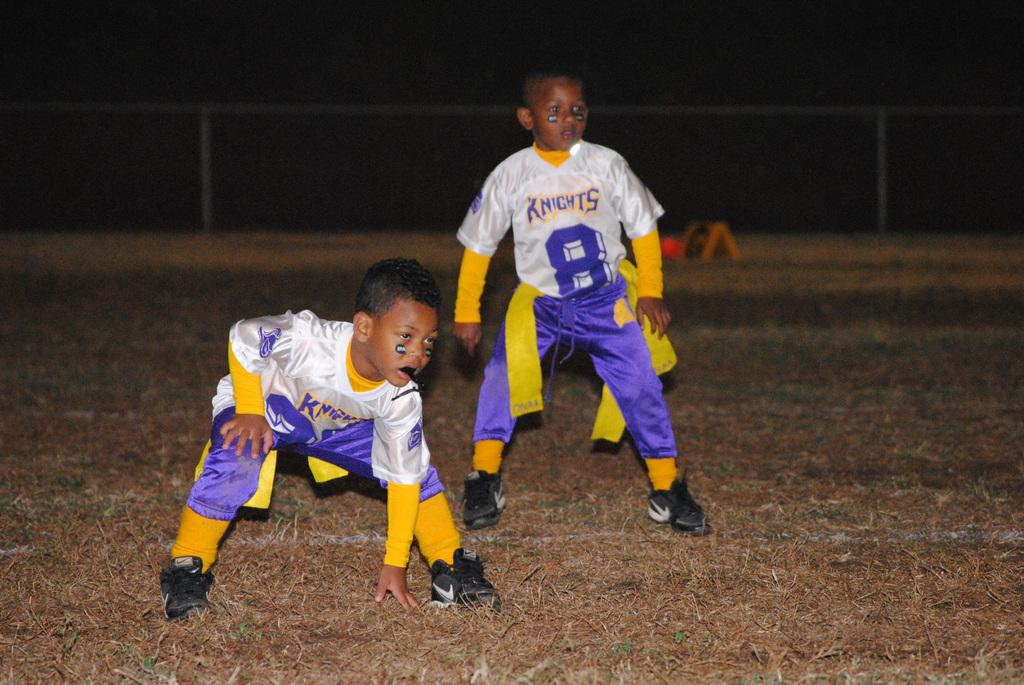Provide a one-sentence caption for the provided image. Two children stand ready to play football, one in a #8 Knights jersey. 